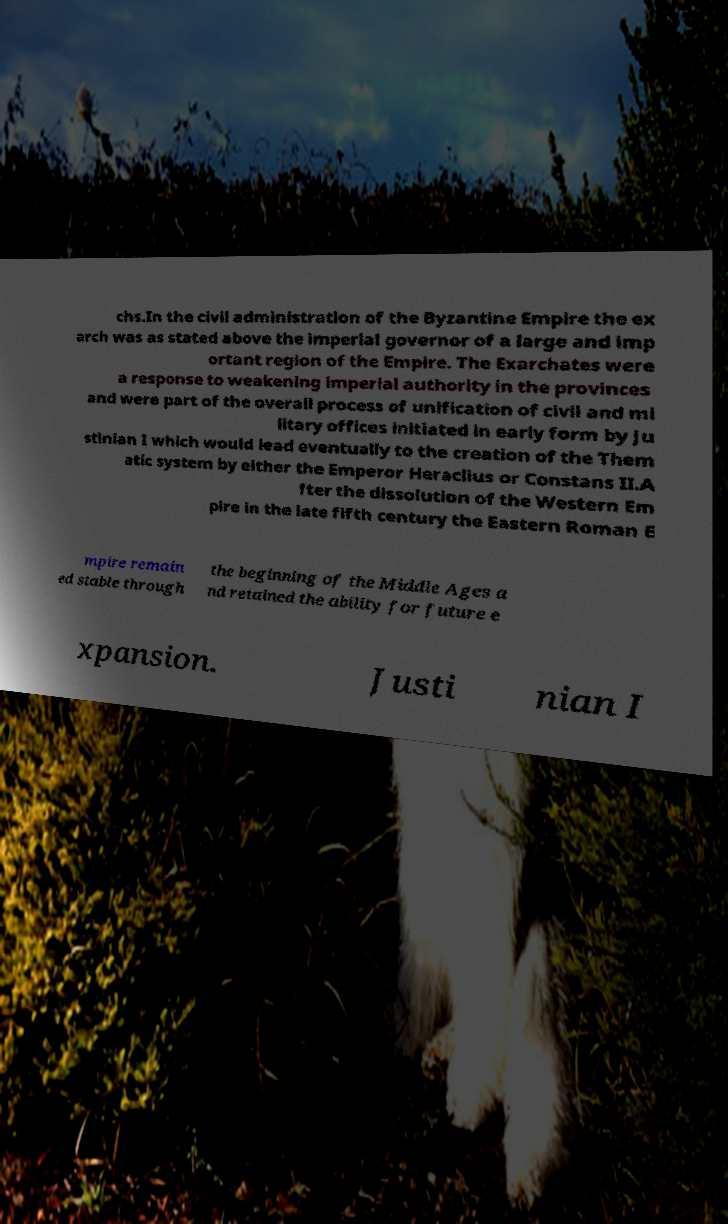I need the written content from this picture converted into text. Can you do that? chs.In the civil administration of the Byzantine Empire the ex arch was as stated above the imperial governor of a large and imp ortant region of the Empire. The Exarchates were a response to weakening imperial authority in the provinces and were part of the overall process of unification of civil and mi litary offices initiated in early form by Ju stinian I which would lead eventually to the creation of the Them atic system by either the Emperor Heraclius or Constans II.A fter the dissolution of the Western Em pire in the late fifth century the Eastern Roman E mpire remain ed stable through the beginning of the Middle Ages a nd retained the ability for future e xpansion. Justi nian I 